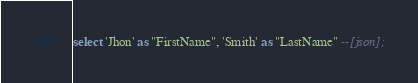<code> <loc_0><loc_0><loc_500><loc_500><_SQL_>
select 'Jhon' as "FirstName", 'Smith' as "LastName" --[json];

</code> 